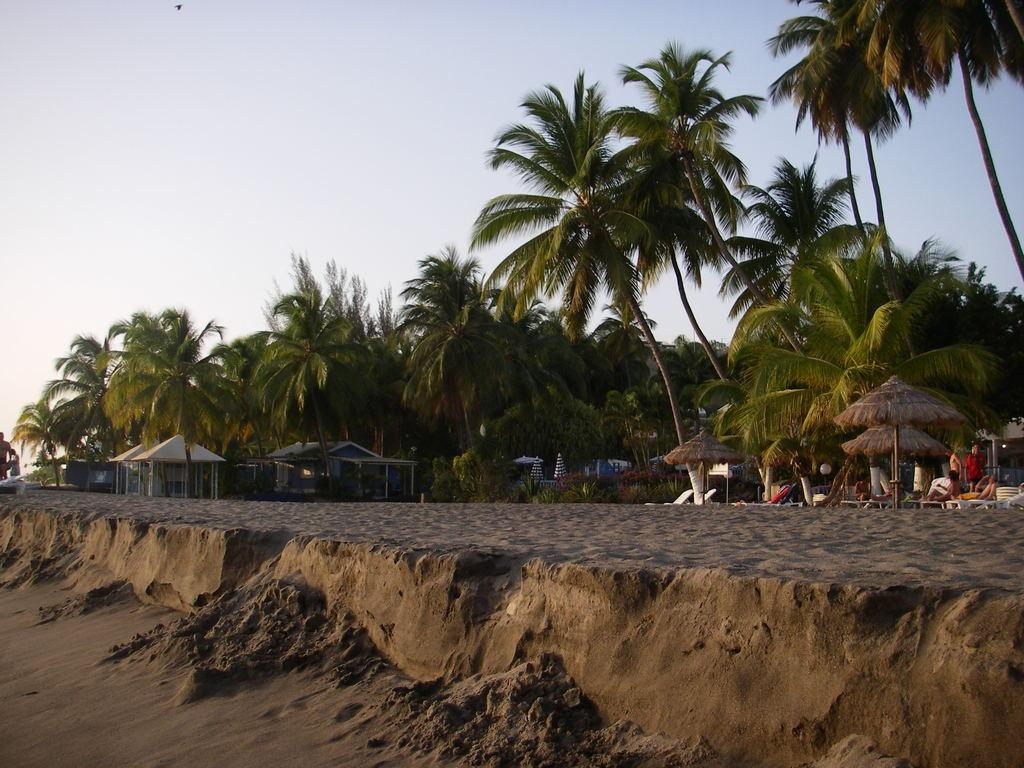What type of vegetation is present in the image? There is a group of trees in the image. What type of structures can be seen in the image? There are houses in the image. What can be found on the right side of the image? There are persons and benches on the right side of the image. What is the texture of the ground in the foreground of the image? There is sand in the foreground of the image. What is visible at the top of the image? The sky is visible at the top of the image. What type of wax can be seen dripping from the boundary in the image? There is no wax or boundary present in the image. What emotion do the persons on the right side of the image seem to be experiencing? The image does not provide enough information to determine the emotions of the persons in the image. 